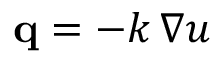<formula> <loc_0><loc_0><loc_500><loc_500>q = - k \, \nabla u</formula> 